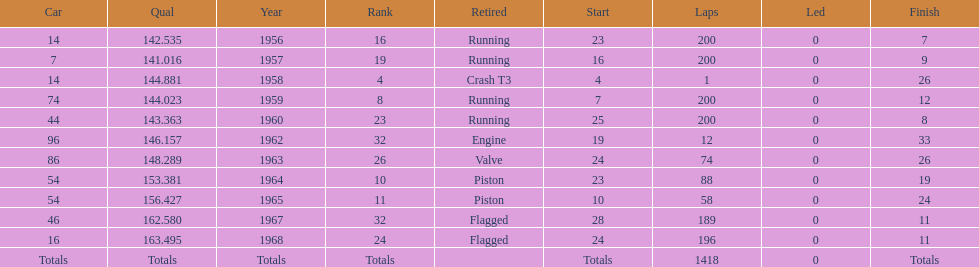What year did he have the same number car as 1964? 1965. 